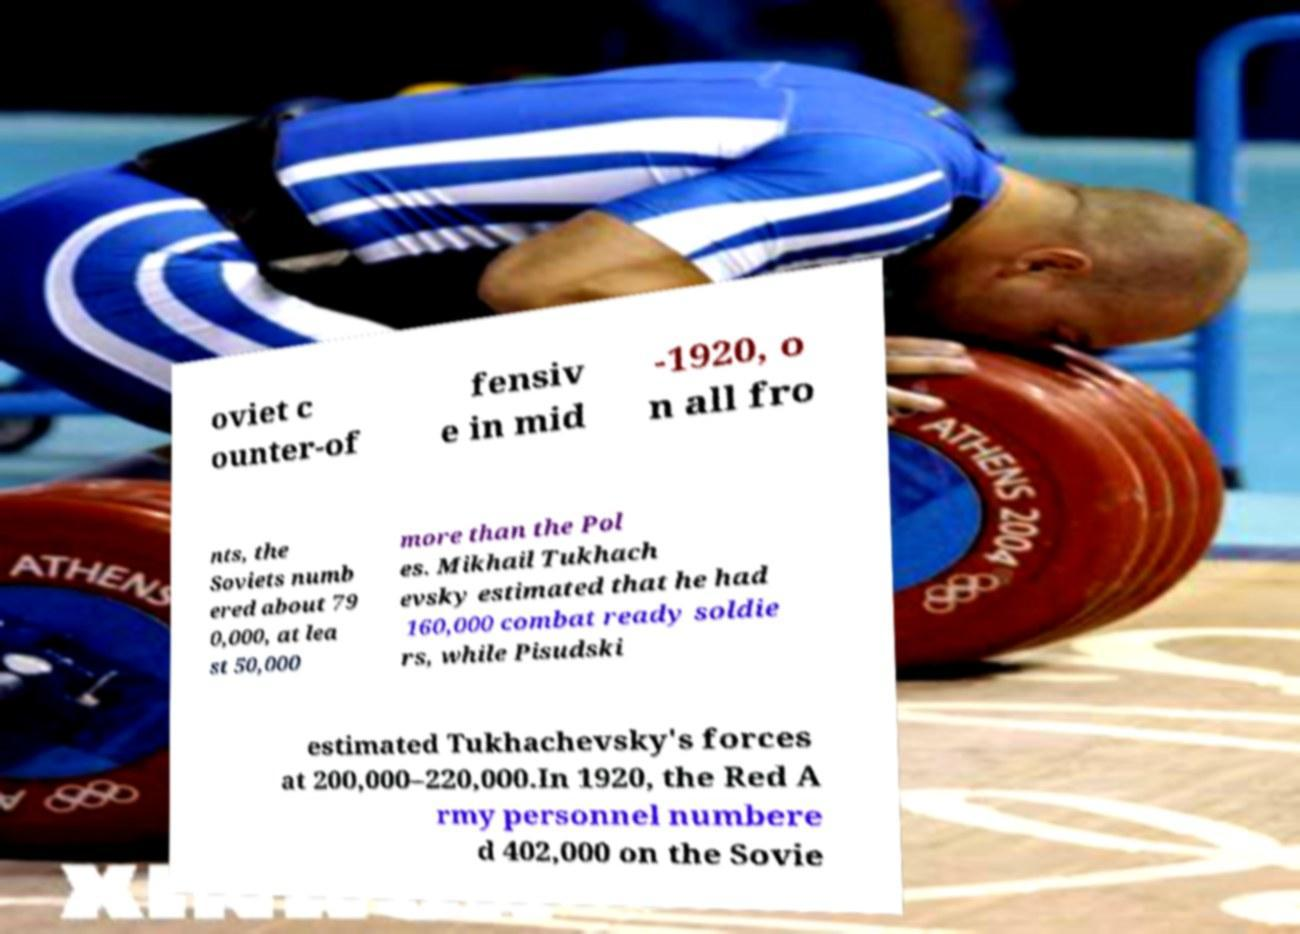Please identify and transcribe the text found in this image. oviet c ounter-of fensiv e in mid -1920, o n all fro nts, the Soviets numb ered about 79 0,000, at lea st 50,000 more than the Pol es. Mikhail Tukhach evsky estimated that he had 160,000 combat ready soldie rs, while Pisudski estimated Tukhachevsky's forces at 200,000–220,000.In 1920, the Red A rmy personnel numbere d 402,000 on the Sovie 